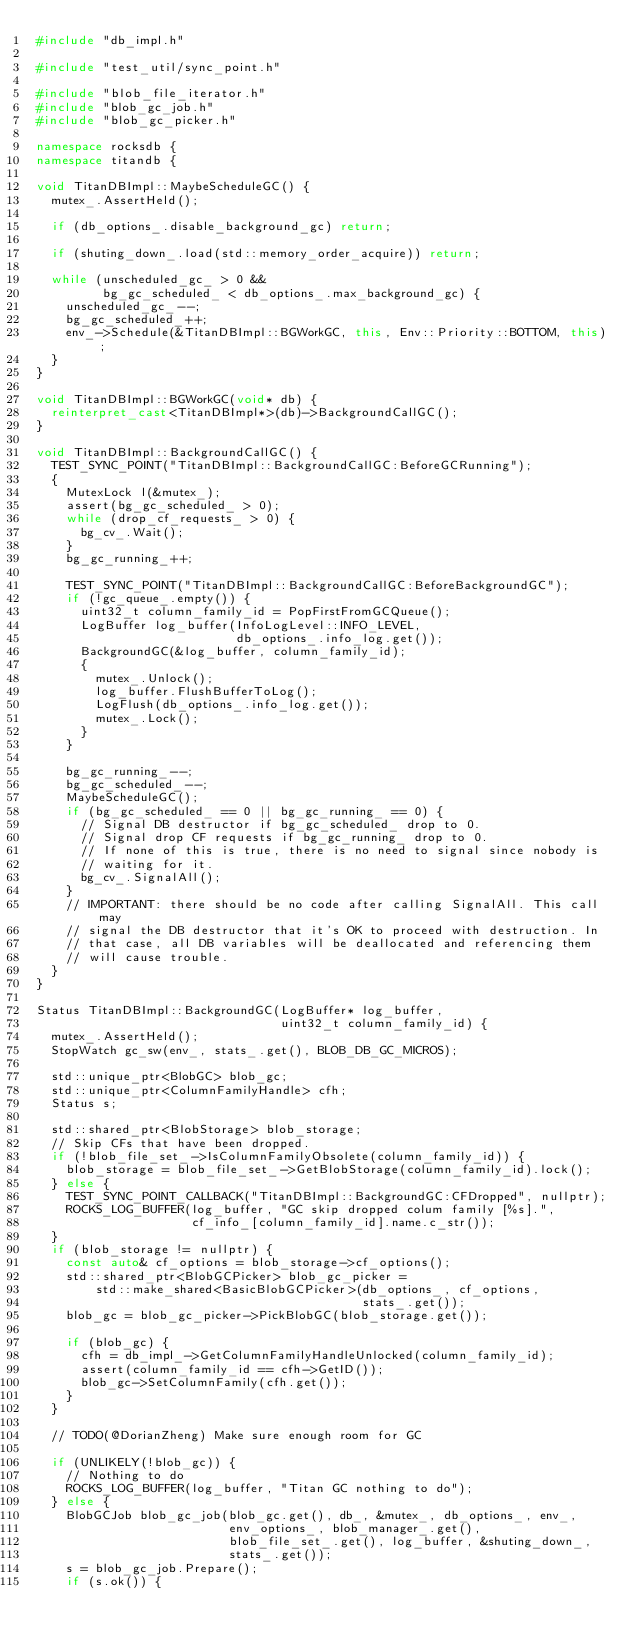Convert code to text. <code><loc_0><loc_0><loc_500><loc_500><_C++_>#include "db_impl.h"

#include "test_util/sync_point.h"

#include "blob_file_iterator.h"
#include "blob_gc_job.h"
#include "blob_gc_picker.h"

namespace rocksdb {
namespace titandb {

void TitanDBImpl::MaybeScheduleGC() {
  mutex_.AssertHeld();

  if (db_options_.disable_background_gc) return;

  if (shuting_down_.load(std::memory_order_acquire)) return;

  while (unscheduled_gc_ > 0 &&
         bg_gc_scheduled_ < db_options_.max_background_gc) {
    unscheduled_gc_--;
    bg_gc_scheduled_++;
    env_->Schedule(&TitanDBImpl::BGWorkGC, this, Env::Priority::BOTTOM, this);
  }
}

void TitanDBImpl::BGWorkGC(void* db) {
  reinterpret_cast<TitanDBImpl*>(db)->BackgroundCallGC();
}

void TitanDBImpl::BackgroundCallGC() {
  TEST_SYNC_POINT("TitanDBImpl::BackgroundCallGC:BeforeGCRunning");
  {
    MutexLock l(&mutex_);
    assert(bg_gc_scheduled_ > 0);
    while (drop_cf_requests_ > 0) {
      bg_cv_.Wait();
    }
    bg_gc_running_++;

    TEST_SYNC_POINT("TitanDBImpl::BackgroundCallGC:BeforeBackgroundGC");
    if (!gc_queue_.empty()) {
      uint32_t column_family_id = PopFirstFromGCQueue();
      LogBuffer log_buffer(InfoLogLevel::INFO_LEVEL,
                           db_options_.info_log.get());
      BackgroundGC(&log_buffer, column_family_id);
      {
        mutex_.Unlock();
        log_buffer.FlushBufferToLog();
        LogFlush(db_options_.info_log.get());
        mutex_.Lock();
      }
    }

    bg_gc_running_--;
    bg_gc_scheduled_--;
    MaybeScheduleGC();
    if (bg_gc_scheduled_ == 0 || bg_gc_running_ == 0) {
      // Signal DB destructor if bg_gc_scheduled_ drop to 0.
      // Signal drop CF requests if bg_gc_running_ drop to 0.
      // If none of this is true, there is no need to signal since nobody is
      // waiting for it.
      bg_cv_.SignalAll();
    }
    // IMPORTANT: there should be no code after calling SignalAll. This call may
    // signal the DB destructor that it's OK to proceed with destruction. In
    // that case, all DB variables will be deallocated and referencing them
    // will cause trouble.
  }
}

Status TitanDBImpl::BackgroundGC(LogBuffer* log_buffer,
                                 uint32_t column_family_id) {
  mutex_.AssertHeld();
  StopWatch gc_sw(env_, stats_.get(), BLOB_DB_GC_MICROS);

  std::unique_ptr<BlobGC> blob_gc;
  std::unique_ptr<ColumnFamilyHandle> cfh;
  Status s;

  std::shared_ptr<BlobStorage> blob_storage;
  // Skip CFs that have been dropped.
  if (!blob_file_set_->IsColumnFamilyObsolete(column_family_id)) {
    blob_storage = blob_file_set_->GetBlobStorage(column_family_id).lock();
  } else {
    TEST_SYNC_POINT_CALLBACK("TitanDBImpl::BackgroundGC:CFDropped", nullptr);
    ROCKS_LOG_BUFFER(log_buffer, "GC skip dropped colum family [%s].",
                     cf_info_[column_family_id].name.c_str());
  }
  if (blob_storage != nullptr) {
    const auto& cf_options = blob_storage->cf_options();
    std::shared_ptr<BlobGCPicker> blob_gc_picker =
        std::make_shared<BasicBlobGCPicker>(db_options_, cf_options,
                                            stats_.get());
    blob_gc = blob_gc_picker->PickBlobGC(blob_storage.get());

    if (blob_gc) {
      cfh = db_impl_->GetColumnFamilyHandleUnlocked(column_family_id);
      assert(column_family_id == cfh->GetID());
      blob_gc->SetColumnFamily(cfh.get());
    }
  }

  // TODO(@DorianZheng) Make sure enough room for GC

  if (UNLIKELY(!blob_gc)) {
    // Nothing to do
    ROCKS_LOG_BUFFER(log_buffer, "Titan GC nothing to do");
  } else {
    BlobGCJob blob_gc_job(blob_gc.get(), db_, &mutex_, db_options_, env_,
                          env_options_, blob_manager_.get(),
                          blob_file_set_.get(), log_buffer, &shuting_down_,
                          stats_.get());
    s = blob_gc_job.Prepare();
    if (s.ok()) {</code> 